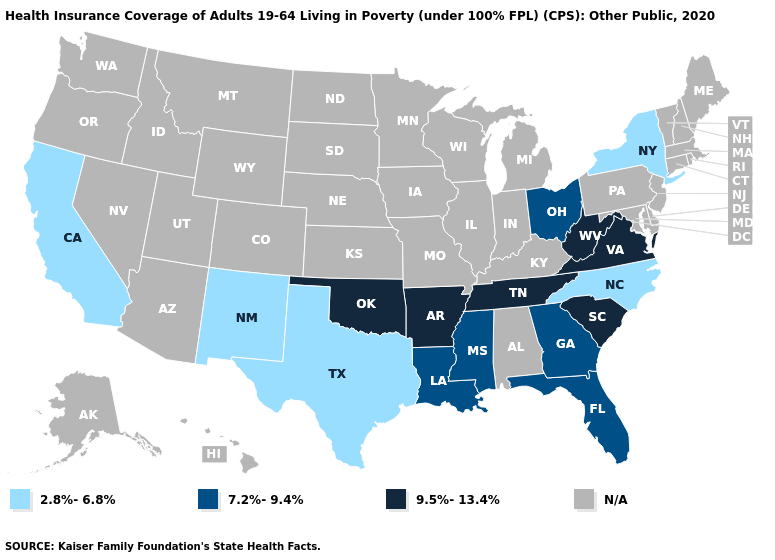What is the value of Massachusetts?
Be succinct. N/A. Does the map have missing data?
Write a very short answer. Yes. Which states hav the highest value in the MidWest?
Answer briefly. Ohio. Name the states that have a value in the range 9.5%-13.4%?
Concise answer only. Arkansas, Oklahoma, South Carolina, Tennessee, Virginia, West Virginia. What is the value of Utah?
Be succinct. N/A. What is the value of Vermont?
Answer briefly. N/A. What is the lowest value in the USA?
Keep it brief. 2.8%-6.8%. Which states have the lowest value in the West?
Write a very short answer. California, New Mexico. What is the value of Florida?
Give a very brief answer. 7.2%-9.4%. Which states have the lowest value in the MidWest?
Give a very brief answer. Ohio. 